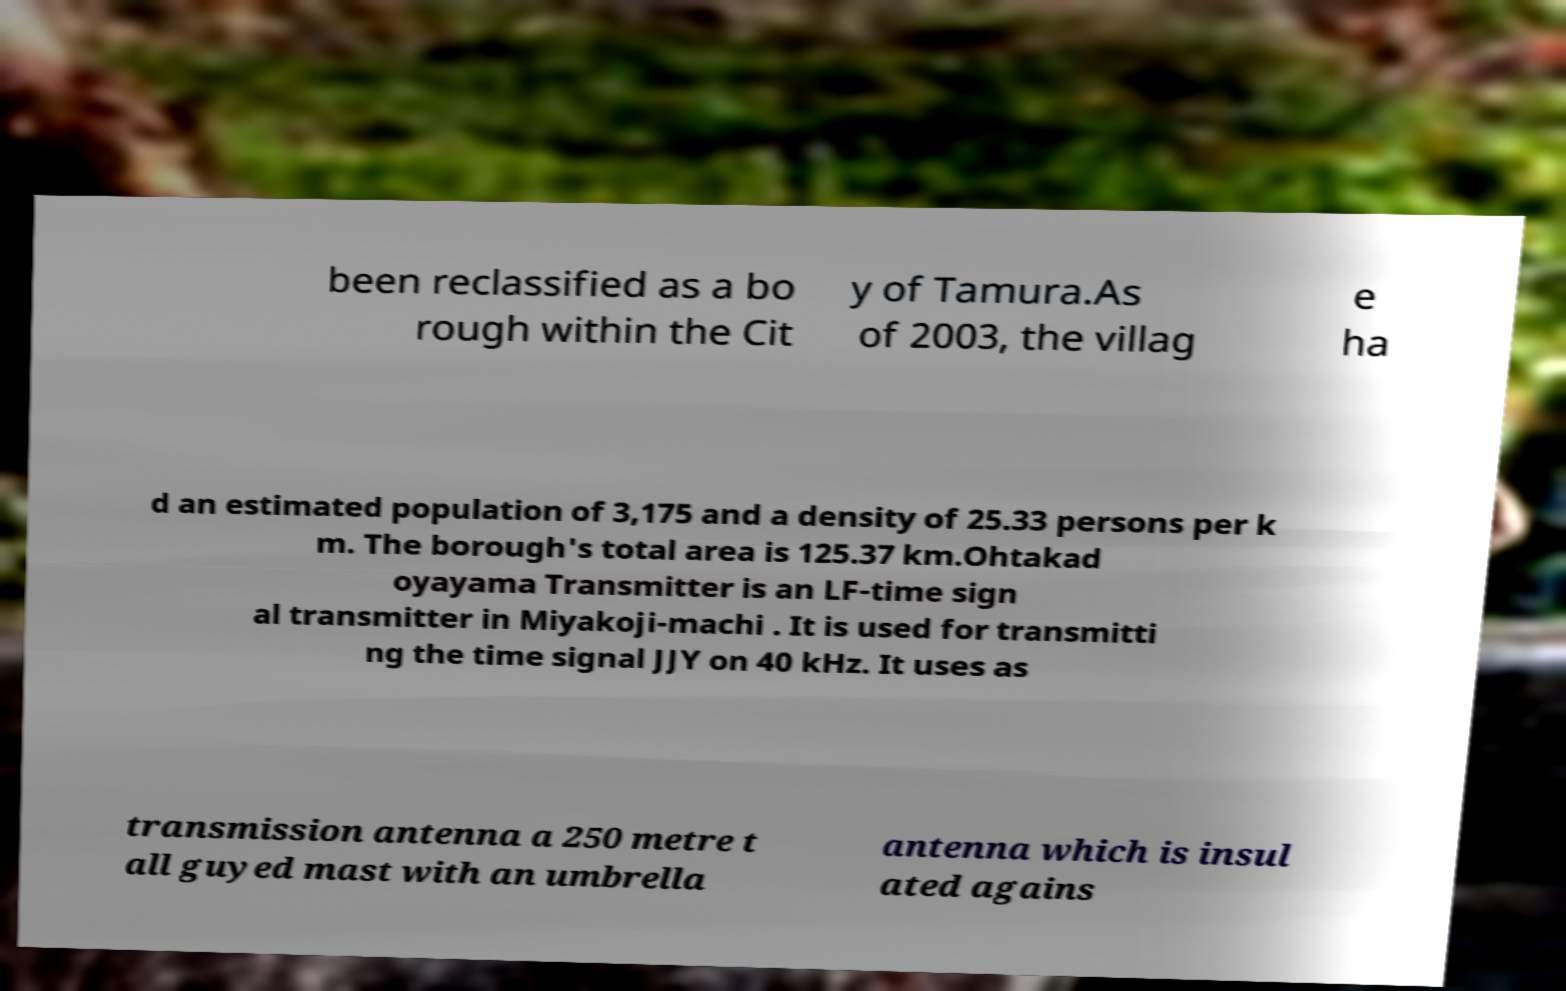Can you accurately transcribe the text from the provided image for me? been reclassified as a bo rough within the Cit y of Tamura.As of 2003, the villag e ha d an estimated population of 3,175 and a density of 25.33 persons per k m. The borough's total area is 125.37 km.Ohtakad oyayama Transmitter is an LF-time sign al transmitter in Miyakoji-machi . It is used for transmitti ng the time signal JJY on 40 kHz. It uses as transmission antenna a 250 metre t all guyed mast with an umbrella antenna which is insul ated agains 